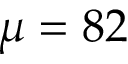Convert formula to latex. <formula><loc_0><loc_0><loc_500><loc_500>\mu = 8 2</formula> 